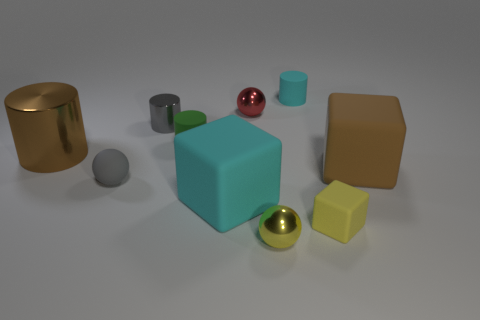There is a matte cylinder left of the cyan matte cylinder; does it have the same color as the thing in front of the tiny cube?
Give a very brief answer. No. How many other things are the same color as the small cube?
Provide a succinct answer. 1. There is a large brown thing that is right of the small yellow cube; what is its shape?
Ensure brevity in your answer.  Cube. Is the number of brown rubber cubes less than the number of matte cylinders?
Ensure brevity in your answer.  Yes. Is the material of the big brown thing that is in front of the large brown metallic cylinder the same as the gray sphere?
Offer a terse response. Yes. Are there any big brown rubber blocks to the left of the tiny green rubber cylinder?
Give a very brief answer. No. There is a large matte cube in front of the large rubber cube behind the cyan object to the left of the tiny cyan matte object; what color is it?
Ensure brevity in your answer.  Cyan. What is the shape of the yellow matte object that is the same size as the yellow sphere?
Offer a terse response. Cube. Are there more yellow shiny balls than blue rubber things?
Make the answer very short. Yes. There is a yellow thing to the left of the small yellow rubber object; are there any large brown things that are on the right side of it?
Your answer should be compact. Yes. 